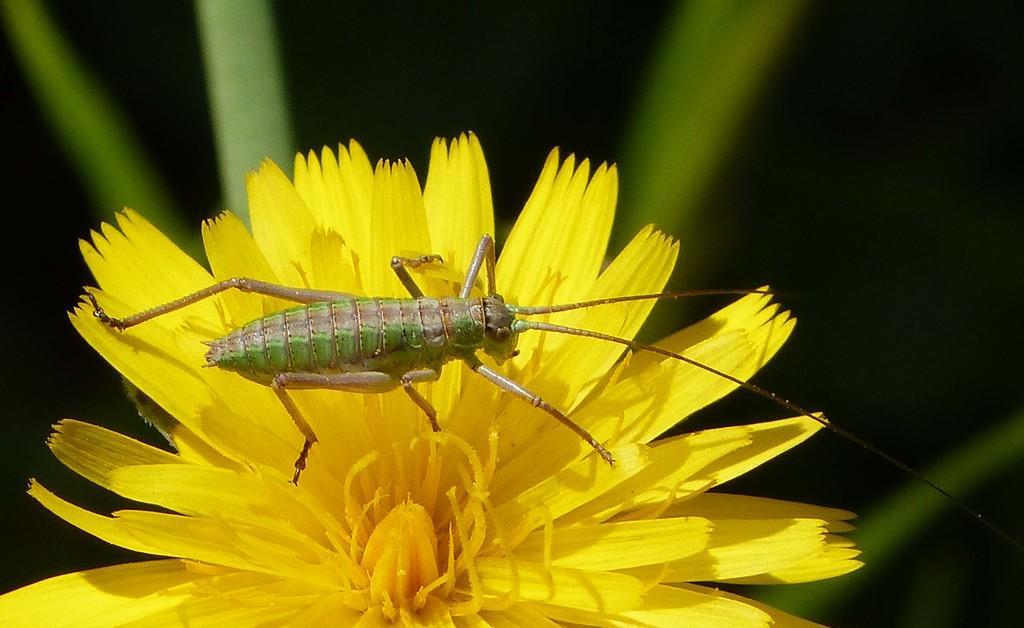In one or two sentences, can you explain what this image depicts? In this picture there is an insect on the yellow color flower. At the bottom there are leaves. 